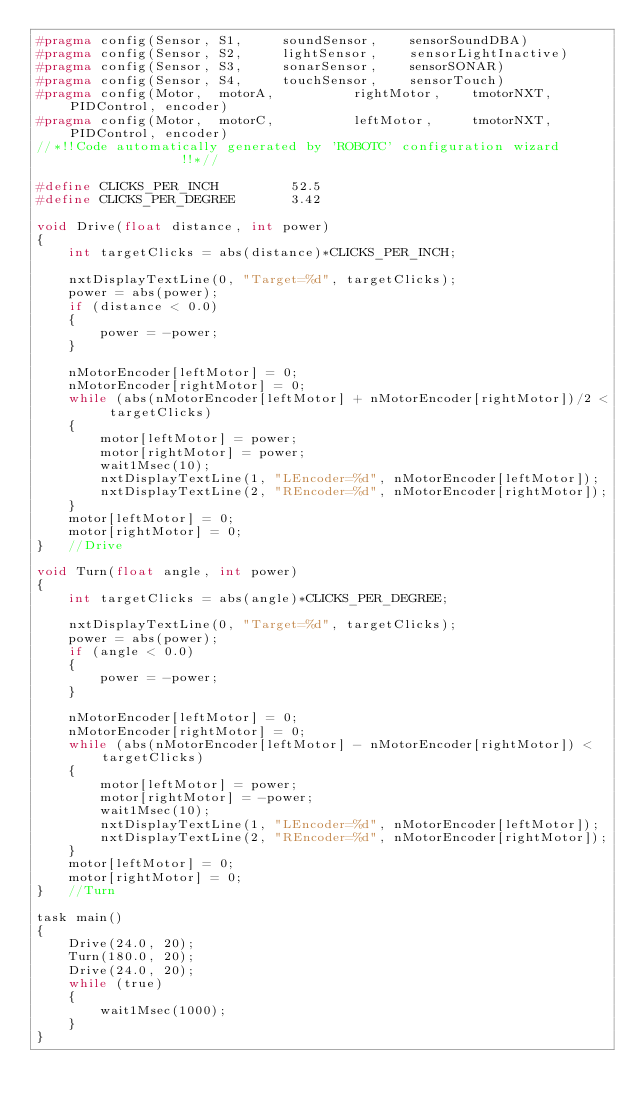Convert code to text. <code><loc_0><loc_0><loc_500><loc_500><_C_>#pragma config(Sensor, S1,     soundSensor,    sensorSoundDBA)
#pragma config(Sensor, S2,     lightSensor,    sensorLightInactive)
#pragma config(Sensor, S3,     sonarSensor,    sensorSONAR)
#pragma config(Sensor, S4,     touchSensor,    sensorTouch)
#pragma config(Motor,  motorA,          rightMotor,    tmotorNXT, PIDControl, encoder)
#pragma config(Motor,  motorC,          leftMotor,     tmotorNXT, PIDControl, encoder)
//*!!Code automatically generated by 'ROBOTC' configuration wizard               !!*//

#define CLICKS_PER_INCH         52.5
#define CLICKS_PER_DEGREE       3.42

void Drive(float distance, int power)
{
    int targetClicks = abs(distance)*CLICKS_PER_INCH;

    nxtDisplayTextLine(0, "Target=%d", targetClicks);
    power = abs(power);
    if (distance < 0.0)
    {
        power = -power;
    }

    nMotorEncoder[leftMotor] = 0;
    nMotorEncoder[rightMotor] = 0;
    while (abs(nMotorEncoder[leftMotor] + nMotorEncoder[rightMotor])/2 < targetClicks)
    {
        motor[leftMotor] = power;
        motor[rightMotor] = power;
        wait1Msec(10);
        nxtDisplayTextLine(1, "LEncoder=%d", nMotorEncoder[leftMotor]);
        nxtDisplayTextLine(2, "REncoder=%d", nMotorEncoder[rightMotor]);
    }
    motor[leftMotor] = 0;
    motor[rightMotor] = 0;
}   //Drive

void Turn(float angle, int power)
{
    int targetClicks = abs(angle)*CLICKS_PER_DEGREE;

    nxtDisplayTextLine(0, "Target=%d", targetClicks);
    power = abs(power);
    if (angle < 0.0)
    {
        power = -power;
    }

    nMotorEncoder[leftMotor] = 0;
    nMotorEncoder[rightMotor] = 0;
    while (abs(nMotorEncoder[leftMotor] - nMotorEncoder[rightMotor]) < targetClicks)
    {
        motor[leftMotor] = power;
        motor[rightMotor] = -power;
        wait1Msec(10);
        nxtDisplayTextLine(1, "LEncoder=%d", nMotorEncoder[leftMotor]);
        nxtDisplayTextLine(2, "REncoder=%d", nMotorEncoder[rightMotor]);
    }
    motor[leftMotor] = 0;
    motor[rightMotor] = 0;
}   //Turn

task main()
{
    Drive(24.0, 20);
    Turn(180.0, 20);
    Drive(24.0, 20);
    while (true)
    {
        wait1Msec(1000);
    }
}
</code> 